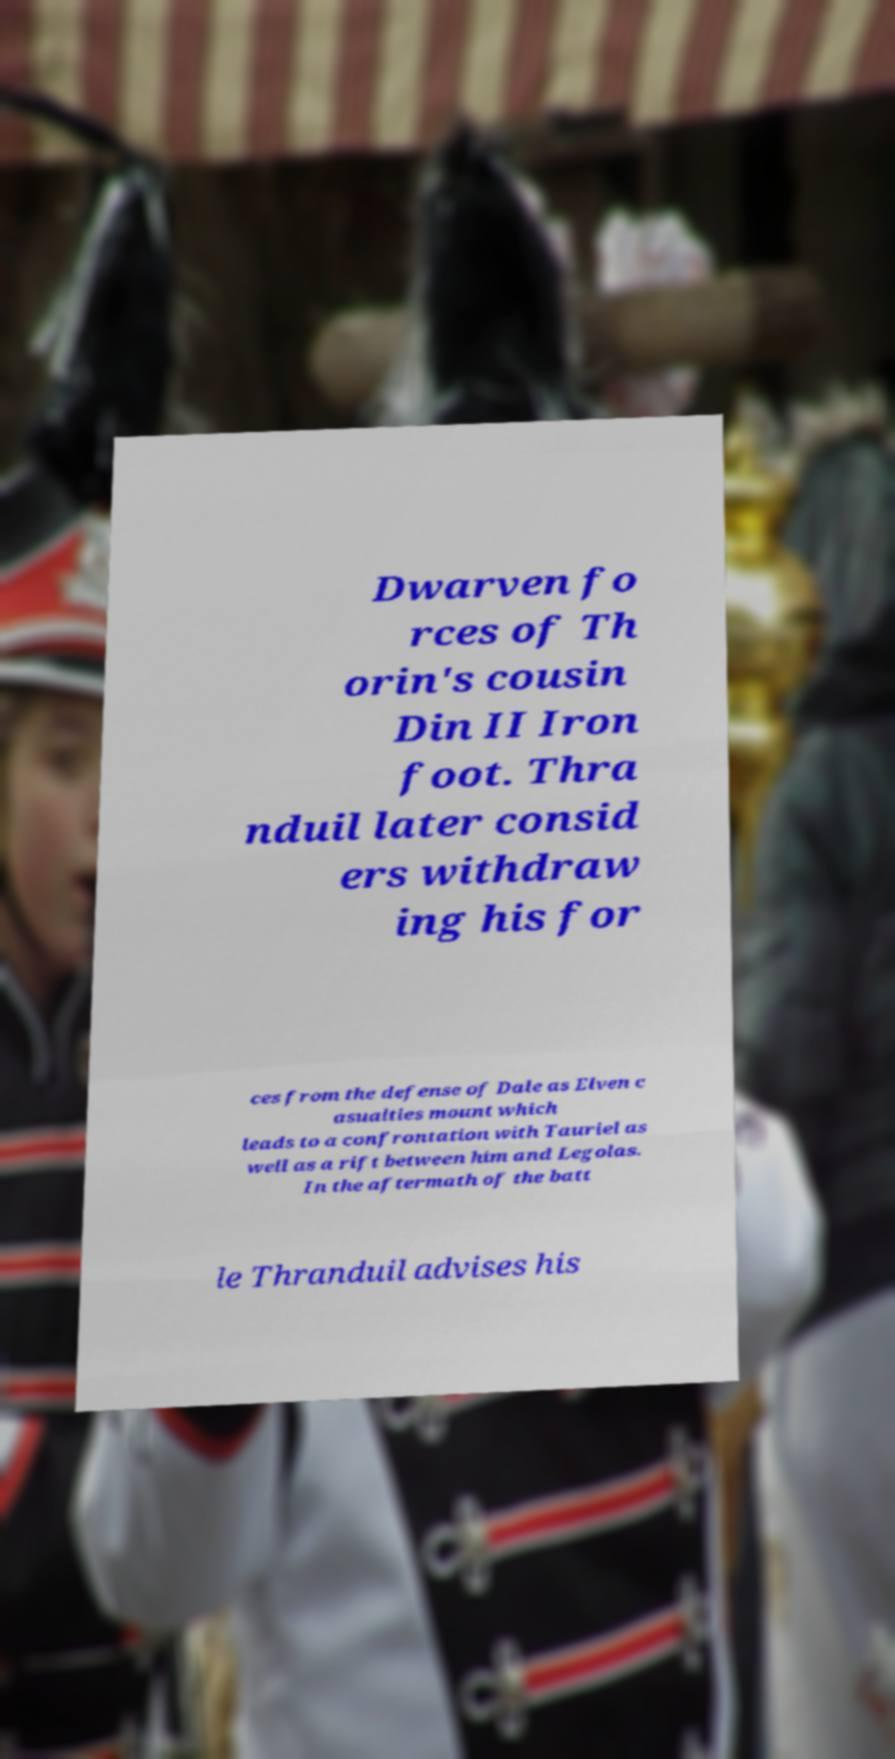There's text embedded in this image that I need extracted. Can you transcribe it verbatim? Dwarven fo rces of Th orin's cousin Din II Iron foot. Thra nduil later consid ers withdraw ing his for ces from the defense of Dale as Elven c asualties mount which leads to a confrontation with Tauriel as well as a rift between him and Legolas. In the aftermath of the batt le Thranduil advises his 